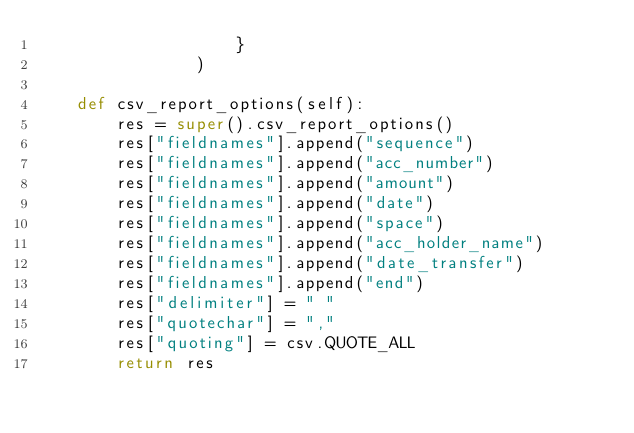<code> <loc_0><loc_0><loc_500><loc_500><_Python_>                    }
                )

    def csv_report_options(self):
        res = super().csv_report_options()
        res["fieldnames"].append("sequence")
        res["fieldnames"].append("acc_number")
        res["fieldnames"].append("amount")
        res["fieldnames"].append("date")
        res["fieldnames"].append("space")
        res["fieldnames"].append("acc_holder_name")
        res["fieldnames"].append("date_transfer")
        res["fieldnames"].append("end")
        res["delimiter"] = " "
        res["quotechar"] = ","
        res["quoting"] = csv.QUOTE_ALL
        return res
</code> 